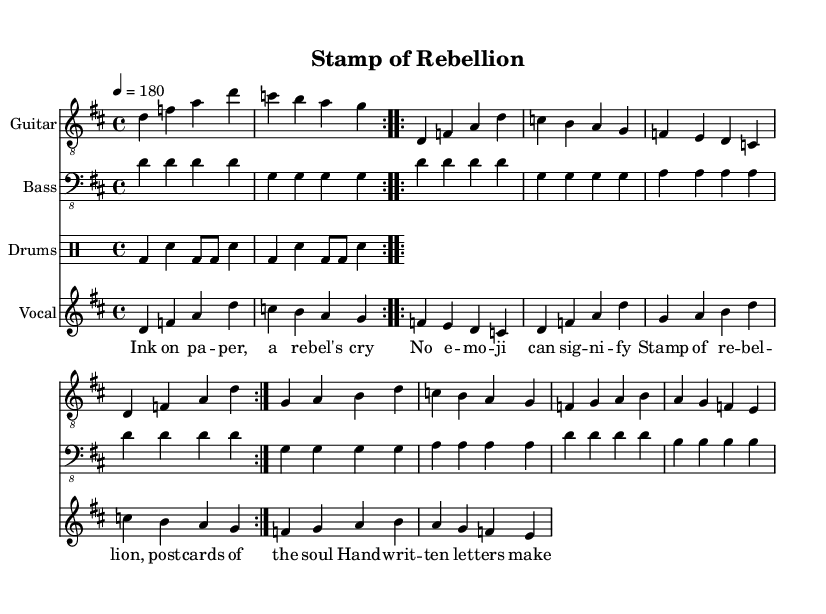What is the key signature of this music? The key signature is indicated at the beginning of the music. The presence of two sharp symbols (F# and C#) signifies the key of D major.
Answer: D major What is the time signature of this piece? The time signature shows how many beats per measure; in this case, it displays a 4 over 4, which means there are four beats in each measure.
Answer: 4/4 What is the tempo marking for this piece? The tempo marking, referenced in the global section, states '4 = 180', indicating that there should be 180 quarter note beats per minute.
Answer: 180 How many measures are in the chorus section? Upon reviewing the chorus part in the sheet music, it consists of four measures, as indicated by the segments provided in that section.
Answer: 4 What type of beat is used in the drum part? The drum part exhibits a basic punk rock beat characterized by kick and snare patterns. The consistency of the kick drum followed by snare notes confirms this.
Answer: Punk rock What do the lyrics convey about the theme of the song? Analyzing the lyrics shows a strong emotional connection to written letters and postcards, framing them as vital expressions of rebellion and authenticity compared to modern digital communication.
Answer: Sentimentality What instruments are featured in the score? The score explicitly enumerates the instruments, mentioning a guitar, bass, drums, and vocals, which together create the signature sound of punk music.
Answer: Guitar, bass, drums, vocals 